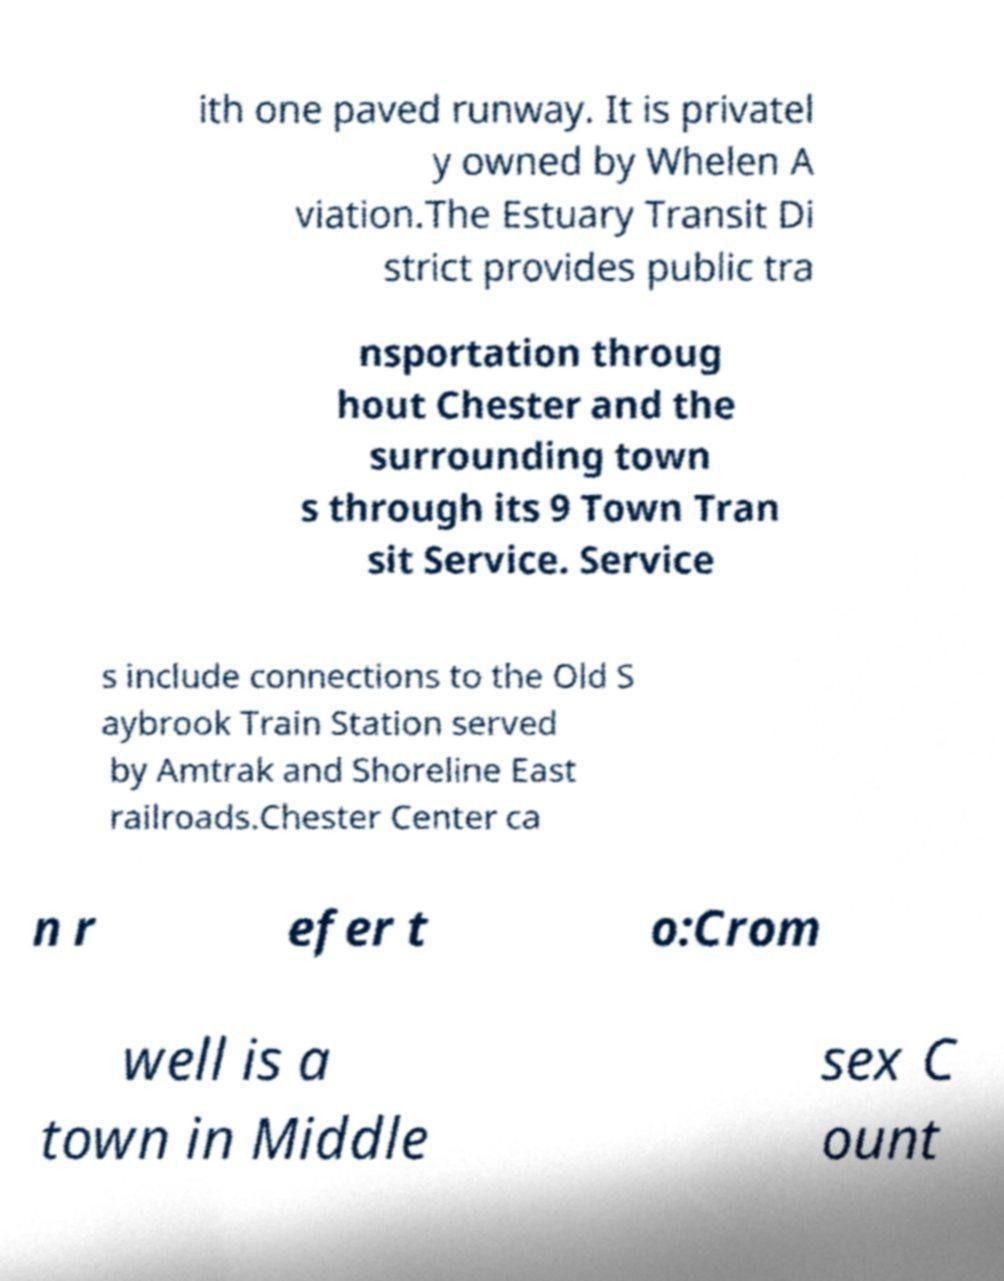What messages or text are displayed in this image? I need them in a readable, typed format. ith one paved runway. It is privatel y owned by Whelen A viation.The Estuary Transit Di strict provides public tra nsportation throug hout Chester and the surrounding town s through its 9 Town Tran sit Service. Service s include connections to the Old S aybrook Train Station served by Amtrak and Shoreline East railroads.Chester Center ca n r efer t o:Crom well is a town in Middle sex C ount 